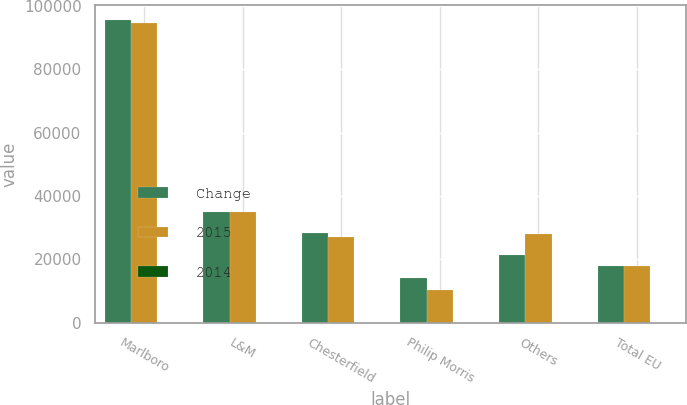<chart> <loc_0><loc_0><loc_500><loc_500><stacked_bar_chart><ecel><fcel>Marlboro<fcel>L&M<fcel>Chesterfield<fcel>Philip Morris<fcel>Others<fcel>Total EU<nl><fcel>Change<fcel>95588<fcel>35010<fcel>28278<fcel>14205<fcel>21508<fcel>17856.5<nl><fcel>2015<fcel>94537<fcel>34943<fcel>27100<fcel>10224<fcel>27942<fcel>17856.5<nl><fcel>2014<fcel>1.1<fcel>0.2<fcel>4.3<fcel>38.9<fcel>23<fcel>0.1<nl></chart> 